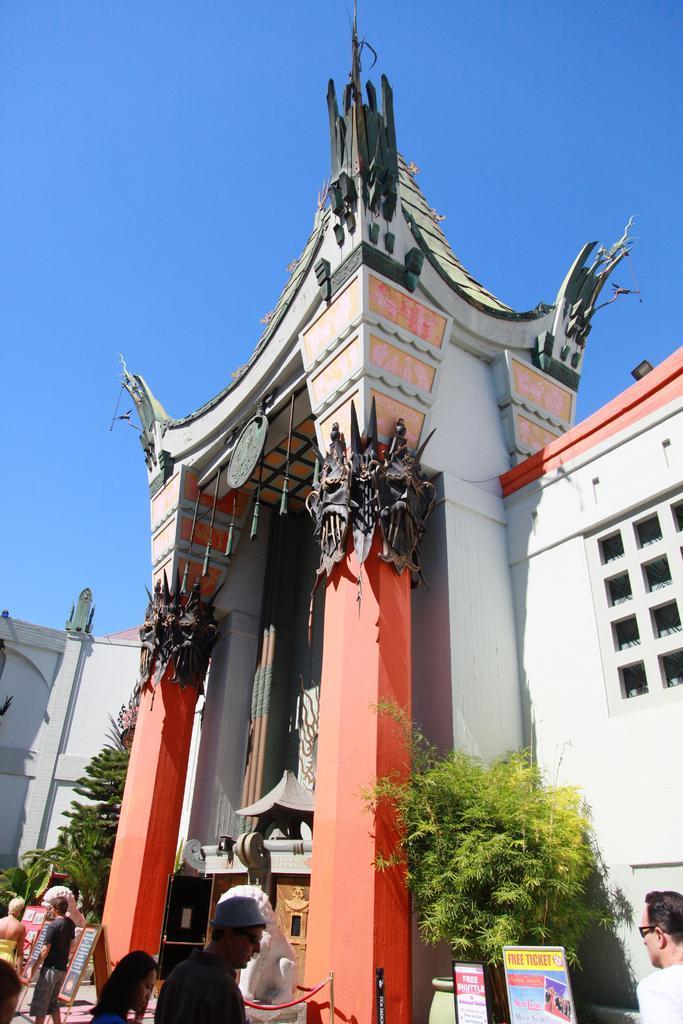Please provide a concise description of this image. In this picture we can see people standing in front of a tall building with trees outside it. 